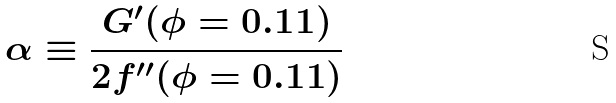Convert formula to latex. <formula><loc_0><loc_0><loc_500><loc_500>\alpha \equiv \frac { G ^ { \prime } ( \phi = 0 . 1 1 ) } { 2 f ^ { \prime \prime } ( \phi = 0 . 1 1 ) }</formula> 